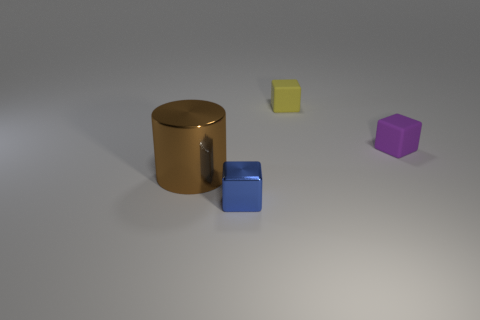Add 4 brown blocks. How many objects exist? 8 Subtract all cubes. How many objects are left? 1 Subtract 0 cyan balls. How many objects are left? 4 Subtract all large rubber objects. Subtract all purple objects. How many objects are left? 3 Add 1 blue things. How many blue things are left? 2 Add 2 purple rubber blocks. How many purple rubber blocks exist? 3 